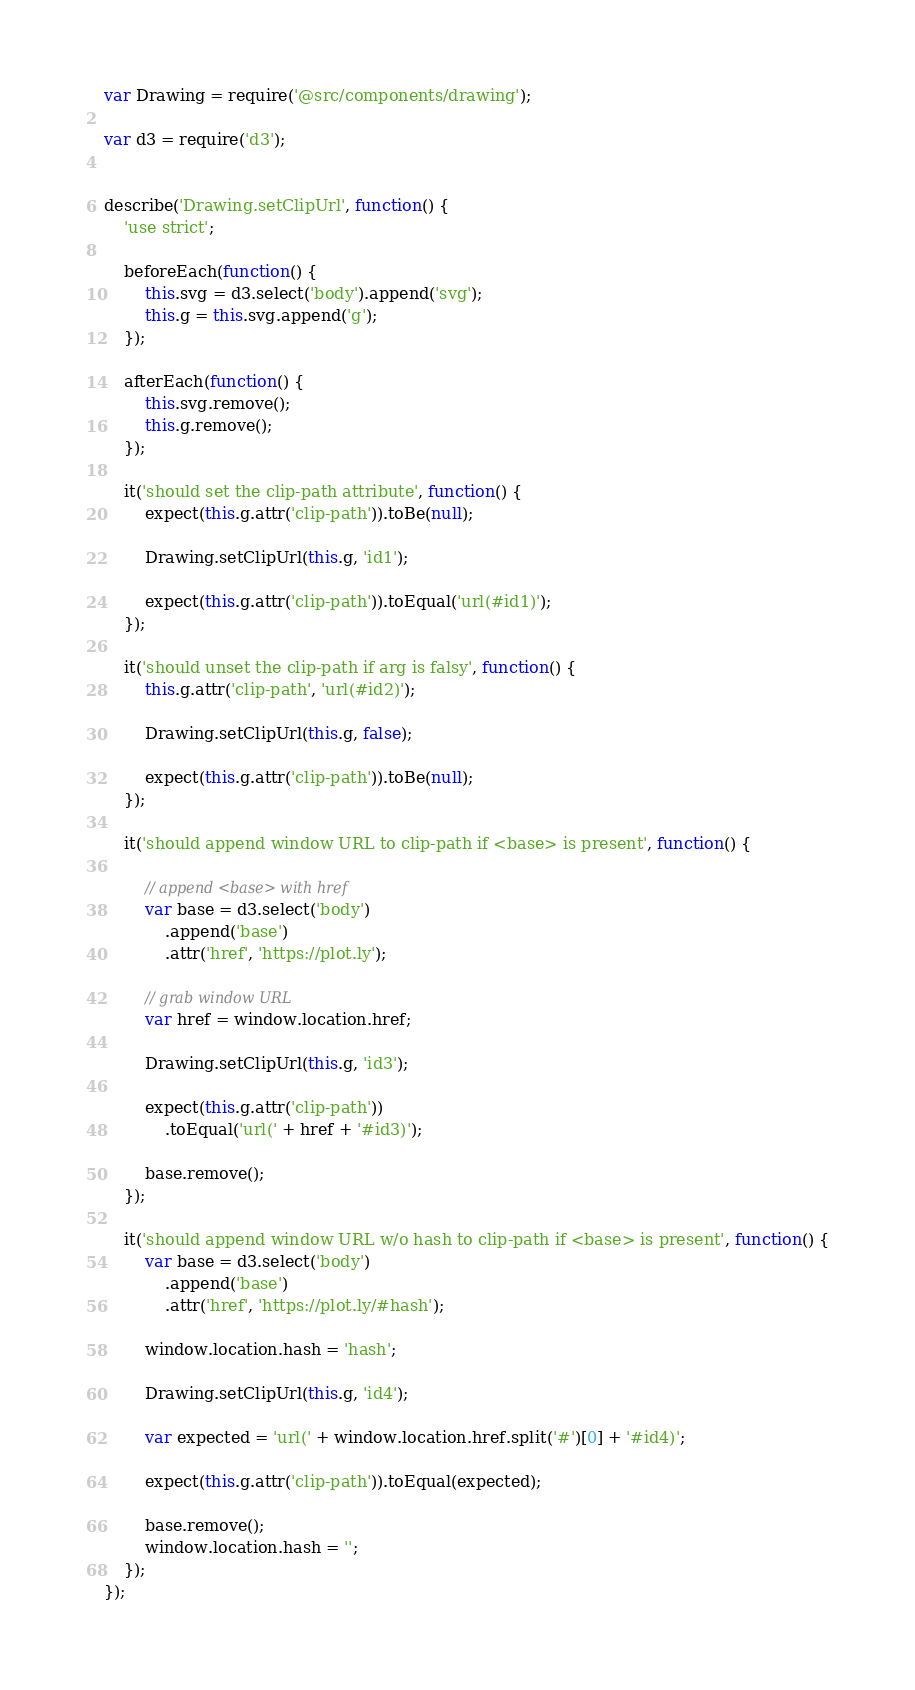Convert code to text. <code><loc_0><loc_0><loc_500><loc_500><_JavaScript_>var Drawing = require('@src/components/drawing');

var d3 = require('d3');


describe('Drawing.setClipUrl', function() {
    'use strict';

    beforeEach(function() {
        this.svg = d3.select('body').append('svg');
        this.g = this.svg.append('g');
    });

    afterEach(function() {
        this.svg.remove();
        this.g.remove();
    });

    it('should set the clip-path attribute', function() {
        expect(this.g.attr('clip-path')).toBe(null);

        Drawing.setClipUrl(this.g, 'id1');

        expect(this.g.attr('clip-path')).toEqual('url(#id1)');
    });

    it('should unset the clip-path if arg is falsy', function() {
        this.g.attr('clip-path', 'url(#id2)');

        Drawing.setClipUrl(this.g, false);

        expect(this.g.attr('clip-path')).toBe(null);
    });

    it('should append window URL to clip-path if <base> is present', function() {

        // append <base> with href
        var base = d3.select('body')
            .append('base')
            .attr('href', 'https://plot.ly');

        // grab window URL
        var href = window.location.href;

        Drawing.setClipUrl(this.g, 'id3');

        expect(this.g.attr('clip-path'))
            .toEqual('url(' + href + '#id3)');

        base.remove();
    });

    it('should append window URL w/o hash to clip-path if <base> is present', function() {
        var base = d3.select('body')
            .append('base')
            .attr('href', 'https://plot.ly/#hash');

        window.location.hash = 'hash';

        Drawing.setClipUrl(this.g, 'id4');

        var expected = 'url(' + window.location.href.split('#')[0] + '#id4)';

        expect(this.g.attr('clip-path')).toEqual(expected);

        base.remove();
        window.location.hash = '';
    });
});
</code> 